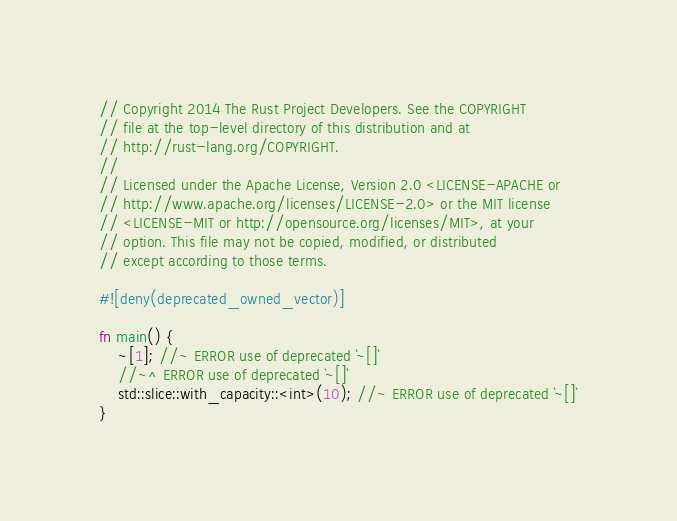<code> <loc_0><loc_0><loc_500><loc_500><_Rust_>// Copyright 2014 The Rust Project Developers. See the COPYRIGHT
// file at the top-level directory of this distribution and at
// http://rust-lang.org/COPYRIGHT.
//
// Licensed under the Apache License, Version 2.0 <LICENSE-APACHE or
// http://www.apache.org/licenses/LICENSE-2.0> or the MIT license
// <LICENSE-MIT or http://opensource.org/licenses/MIT>, at your
// option. This file may not be copied, modified, or distributed
// except according to those terms.

#![deny(deprecated_owned_vector)]

fn main() {
    ~[1]; //~ ERROR use of deprecated `~[]`
    //~^ ERROR use of deprecated `~[]`
    std::slice::with_capacity::<int>(10); //~ ERROR use of deprecated `~[]`
}
</code> 